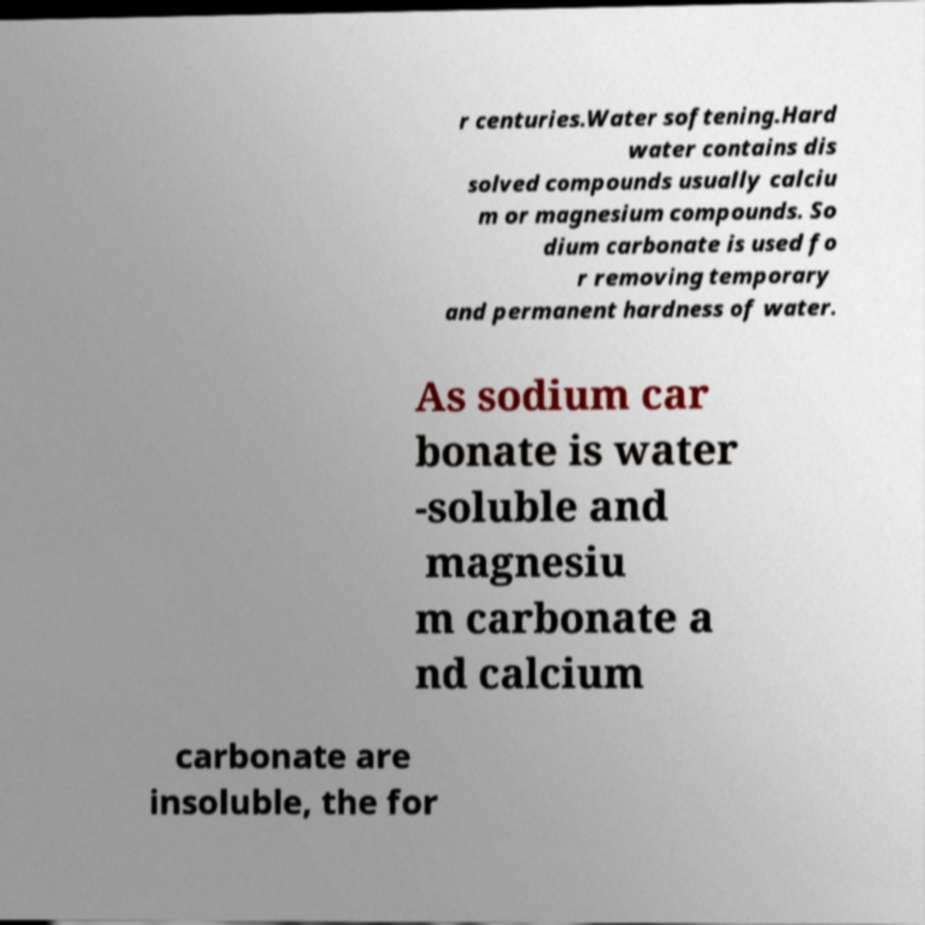For documentation purposes, I need the text within this image transcribed. Could you provide that? r centuries.Water softening.Hard water contains dis solved compounds usually calciu m or magnesium compounds. So dium carbonate is used fo r removing temporary and permanent hardness of water. As sodium car bonate is water -soluble and magnesiu m carbonate a nd calcium carbonate are insoluble, the for 